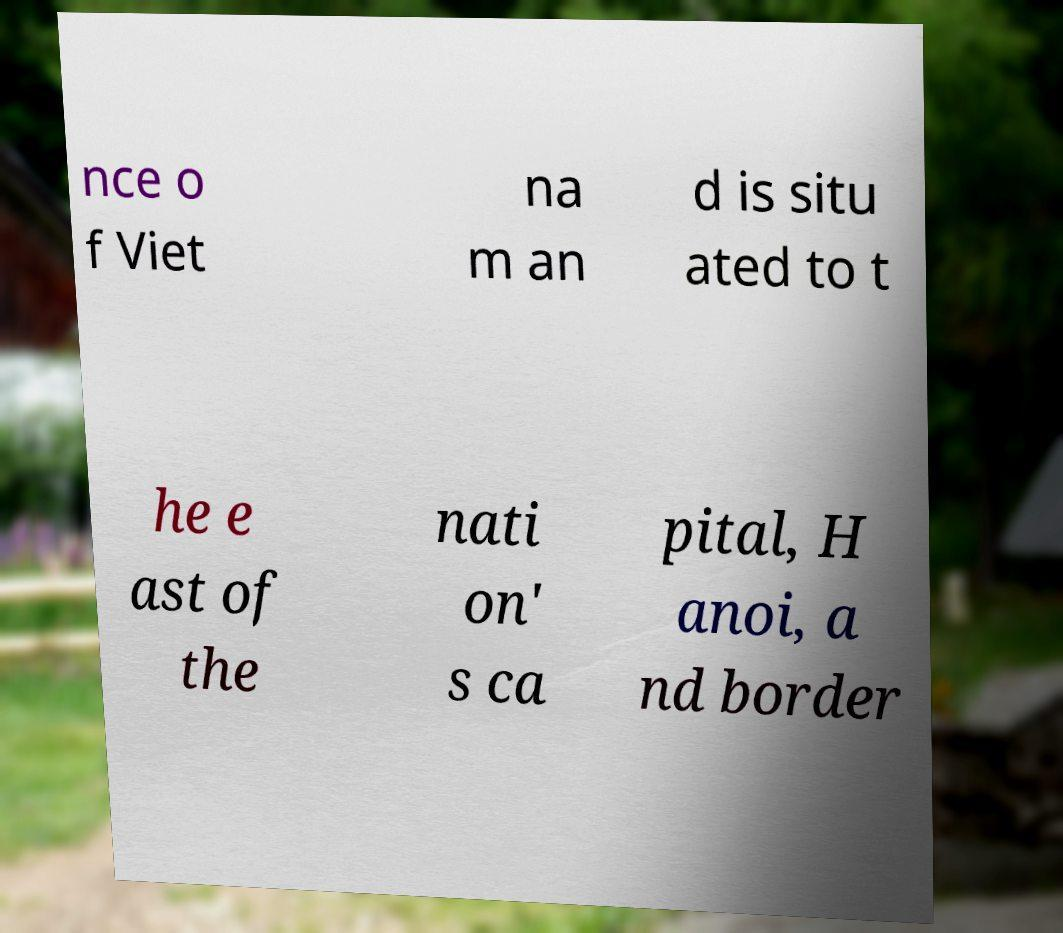Can you read and provide the text displayed in the image?This photo seems to have some interesting text. Can you extract and type it out for me? nce o f Viet na m an d is situ ated to t he e ast of the nati on' s ca pital, H anoi, a nd border 